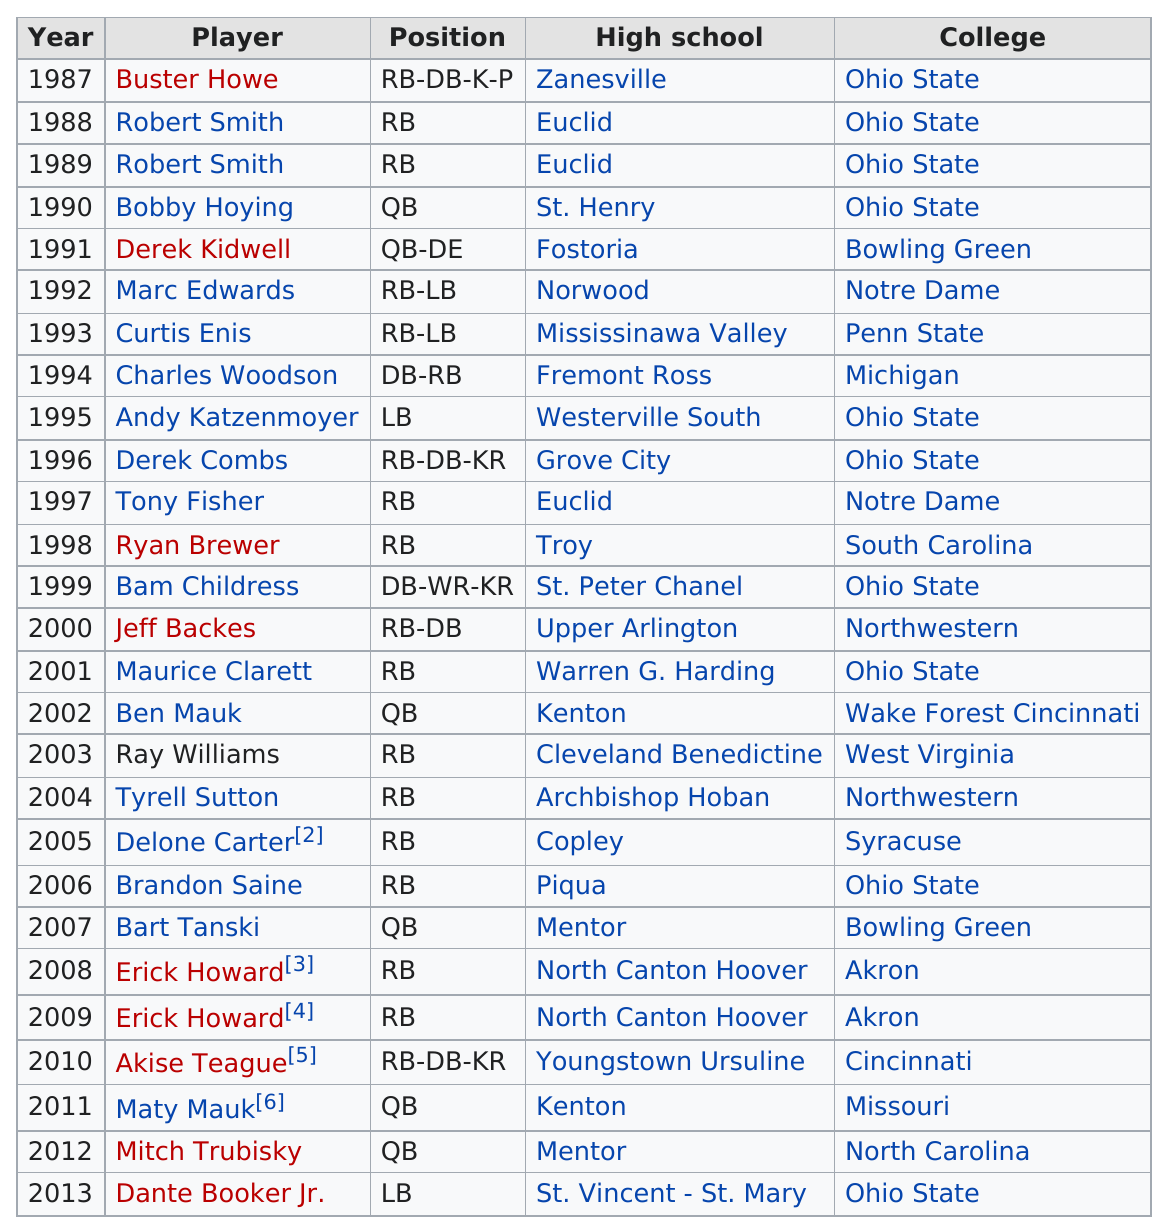Highlight a few significant elements in this photo. After Ben Mauk, Ray Williams was the player of the year. In the year following Buster Howe's victory, Robert Smith was declared the winner. Tony Fisher and Ryan Brewer each played the position of running back. Ohio State achieved 10 wins. Buster Howe was the player of the year before Robert Smith. 